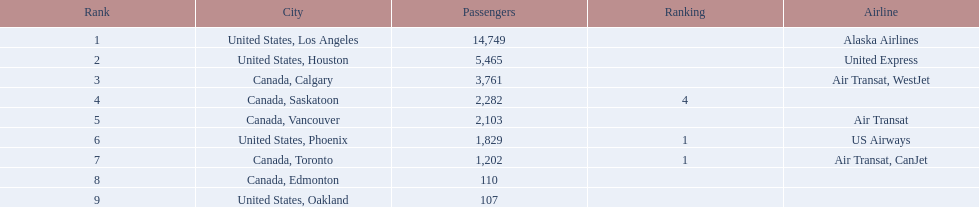What are the numbers in the passengers column? 14,749, 5,465, 3,761, 2,282, 2,103, 1,829, 1,202, 110, 107. Which of these numbers is the least? 107. Which city is connected to this least number? United States, Oakland. 